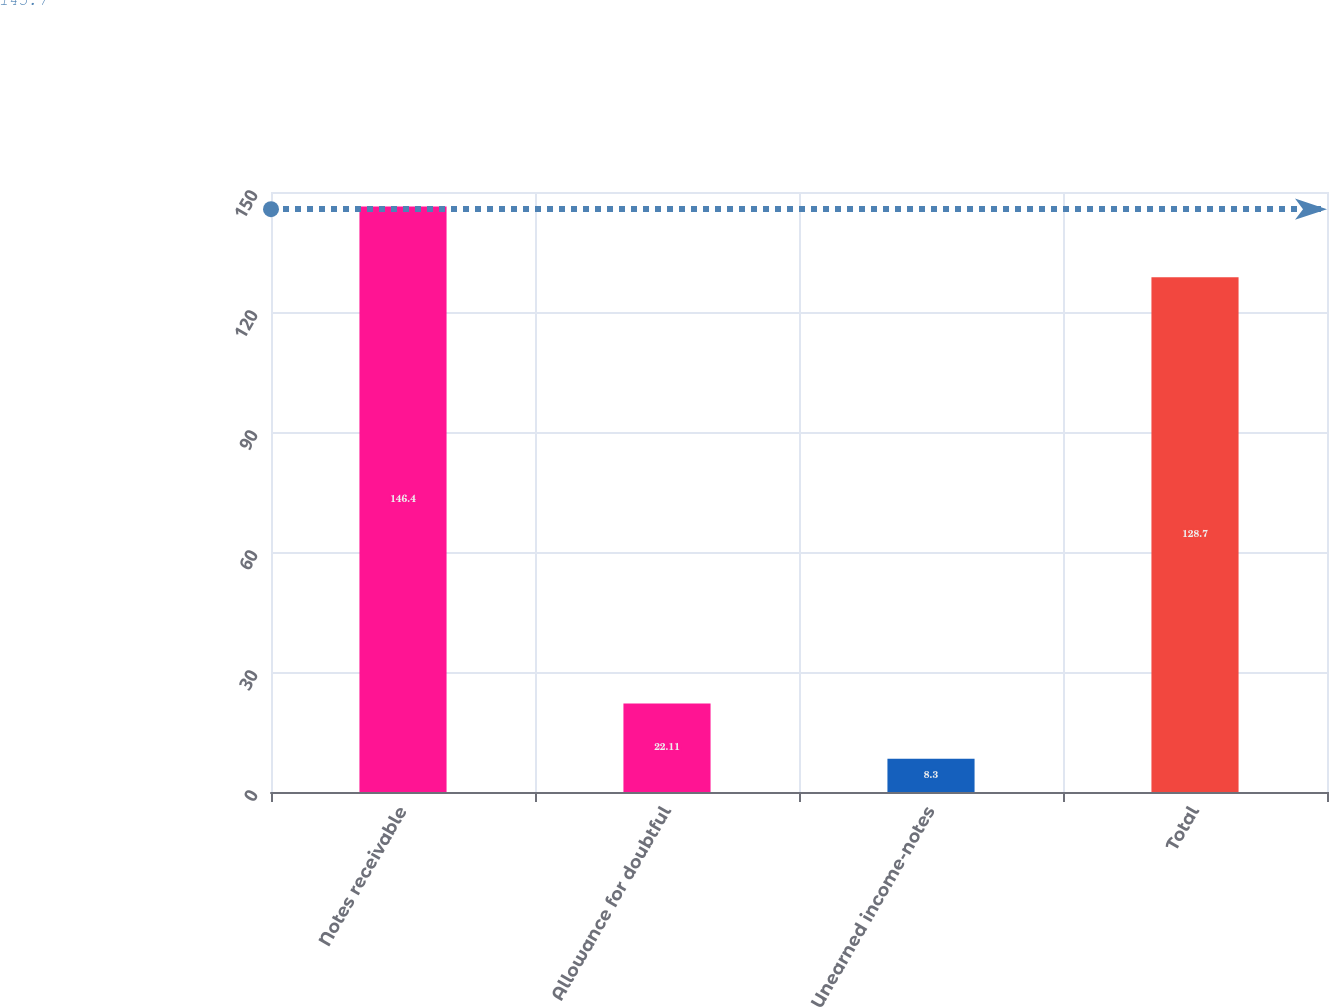Convert chart. <chart><loc_0><loc_0><loc_500><loc_500><bar_chart><fcel>Notes receivable<fcel>Allowance for doubtful<fcel>Unearned income-notes<fcel>Total<nl><fcel>146.4<fcel>22.11<fcel>8.3<fcel>128.7<nl></chart> 